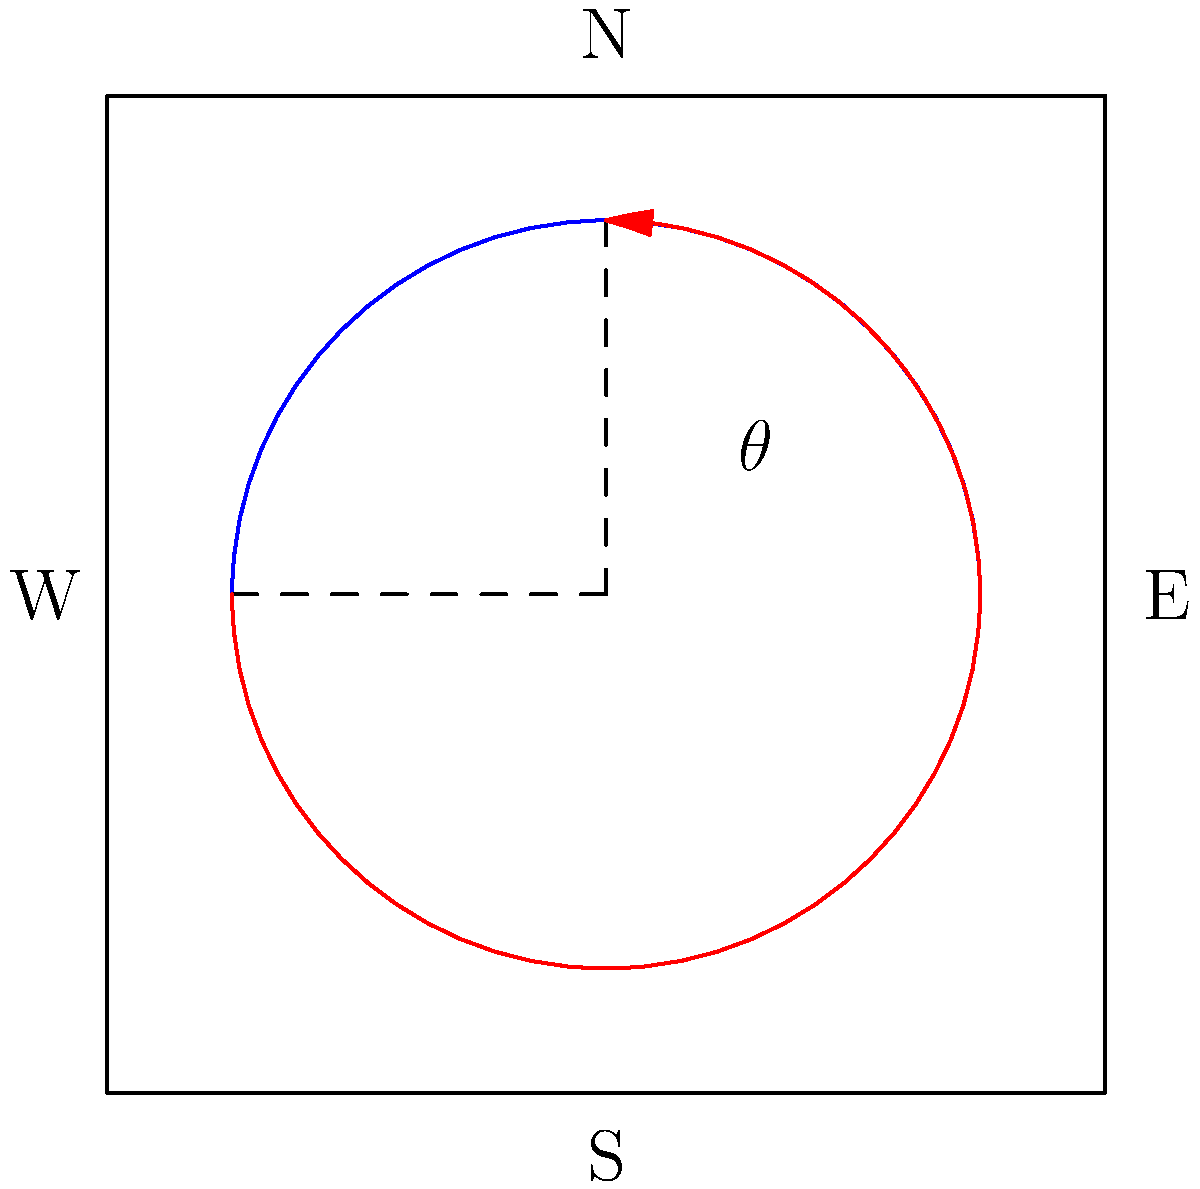A cylindrical silo is currently positioned with its shadow falling directly west at noon. To maximize sunlight exposure for the surrounding crops, you need to rotate the silo counterclockwise. If the optimal angle for sunlight distribution is 60° northeast of the current position, by how many degrees should you rotate the silo? Let's approach this step-by-step:

1) The silo's current position casts a shadow directly west at noon, which means the sun is directly south of the silo.

2) The optimal position is described as 60° northeast of the current position. This means we need to rotate the silo so that its optimal shadow direction is 60° counterclockwise from west.

3) In the diagram, west is represented by the negative x-axis, and north by the positive y-axis.

4) The angle we're looking for ($\theta$) is the rotation needed to move from the current position (shadow pointing west) to the optimal position (60° northeast of west).

5) We can calculate this angle as follows:
   - A full rotation from west to west (counterclockwise) is 360°
   - From west to north is 90°
   - The optimal position is 60° beyond north, so it's at 90° + 60° = 150° from the starting position

6) Therefore, the rotation angle $\theta$ is 150°.
Answer: 150° 